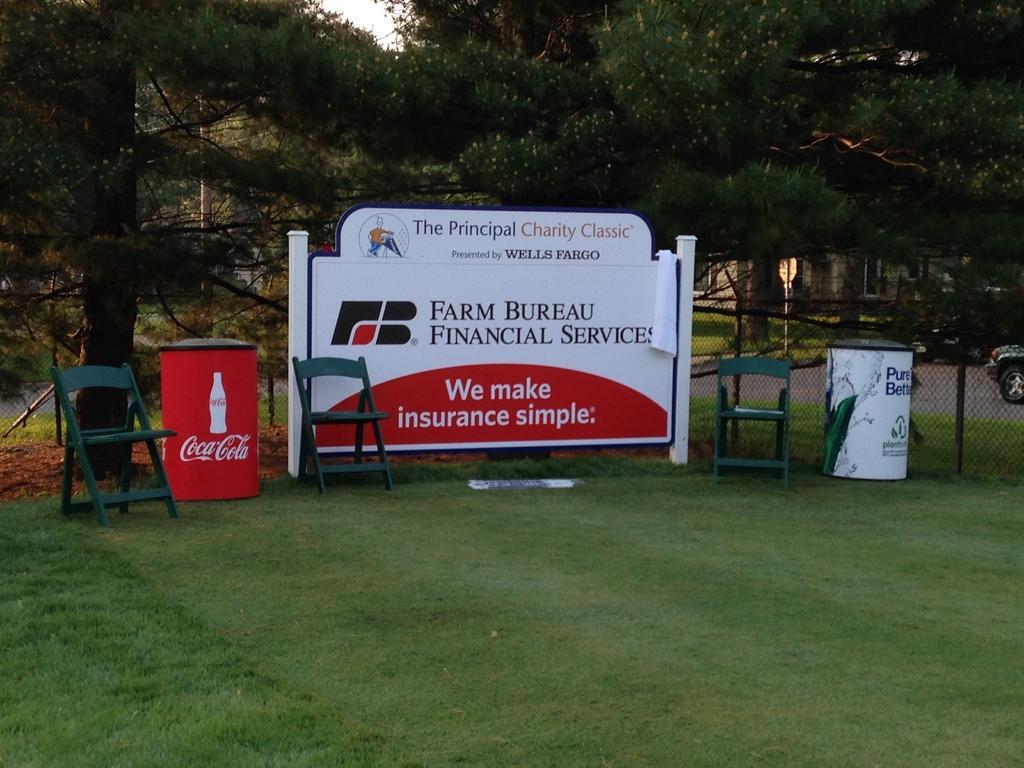Could you give a brief overview of what you see in this image? In the given image i can see a chairs,trees,grass,fence,vehicles,poles,house,board with some text and some other objects. 